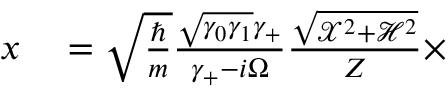Convert formula to latex. <formula><loc_0><loc_0><loc_500><loc_500>\begin{array} { r l } { x } & = \sqrt { \frac { } { m } } \frac { \sqrt { \gamma _ { 0 } \gamma _ { 1 } } \gamma _ { + } } { \gamma _ { + } - i \Omega } \frac { \sqrt { \mathcal { X } ^ { 2 } + \mathcal { H } ^ { 2 } } } { Z } \times } \end{array}</formula> 